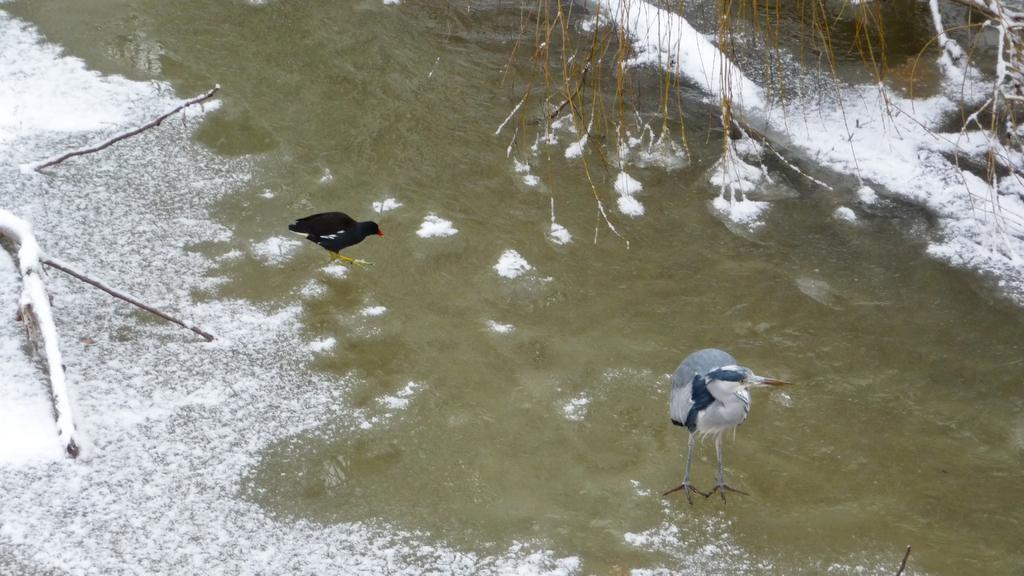Could you give a brief overview of what you see in this image? In this image there is a hen and there is a duck on the water, in this image there are dried branches with snow. 